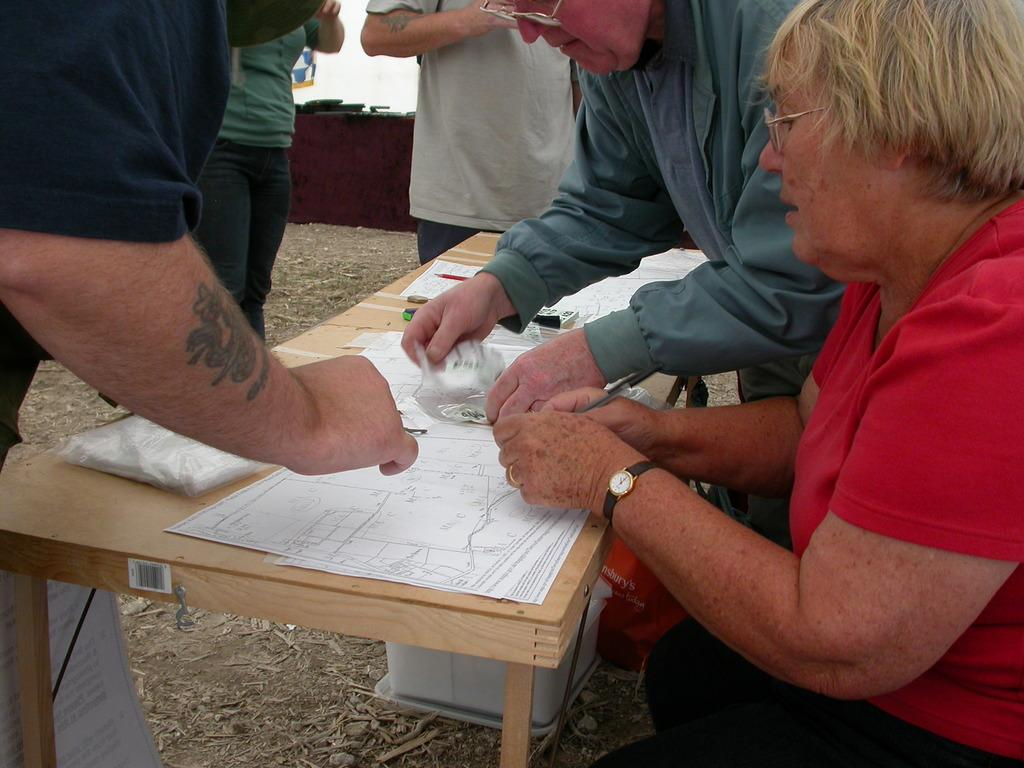What is the location of the people in the image? The people are in front of the table in the image. What is on the table in the image? There are papers on the table in the image. Can you see a lake in the background of the image? There is no lake visible in the image. Are there any gloves on the table in the image? There are no gloves present in the image. 